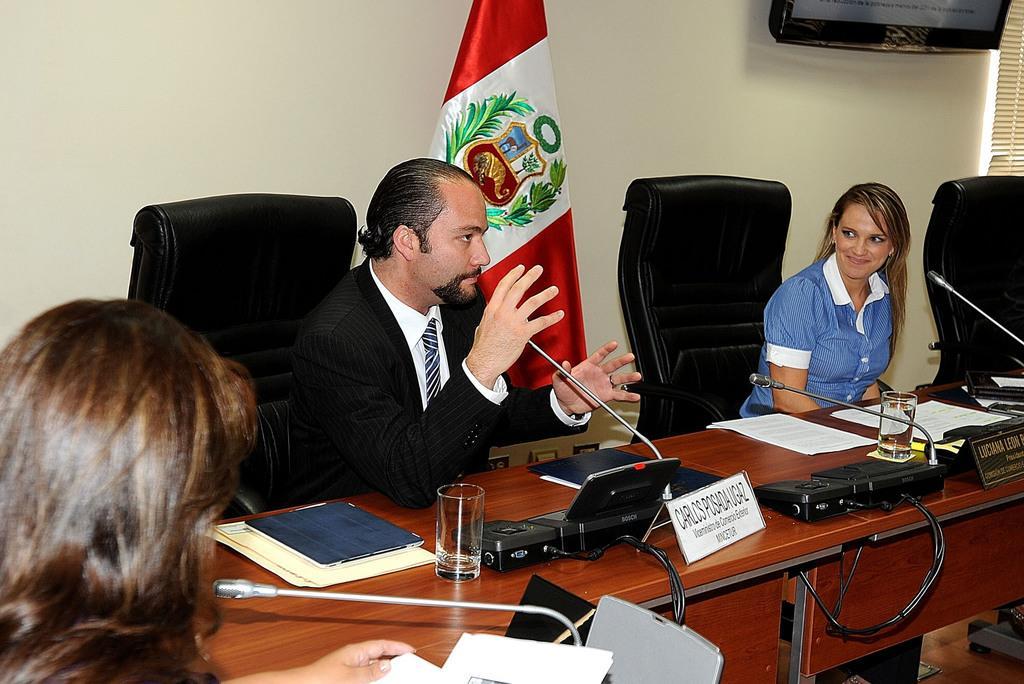How would you summarize this image in a sentence or two? In the image there are three people sitting on chairs at the table. On the table there is a name board, papers, class, microphones and files. Behind the man there is flag. In the background there is wall, television and window blinds. 